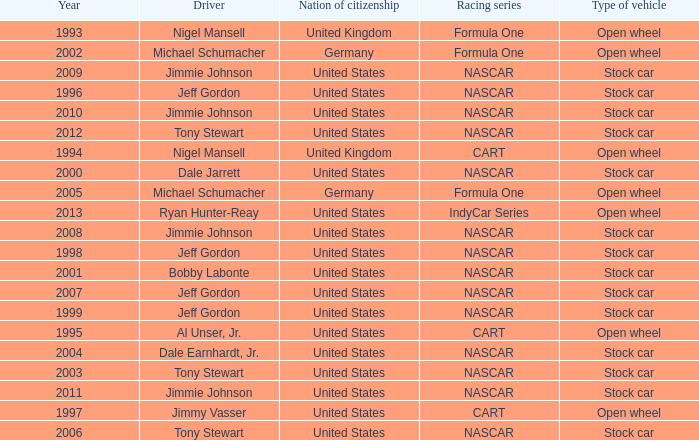Parse the table in full. {'header': ['Year', 'Driver', 'Nation of citizenship', 'Racing series', 'Type of vehicle'], 'rows': [['1993', 'Nigel Mansell', 'United Kingdom', 'Formula One', 'Open wheel'], ['2002', 'Michael Schumacher', 'Germany', 'Formula One', 'Open wheel'], ['2009', 'Jimmie Johnson', 'United States', 'NASCAR', 'Stock car'], ['1996', 'Jeff Gordon', 'United States', 'NASCAR', 'Stock car'], ['2010', 'Jimmie Johnson', 'United States', 'NASCAR', 'Stock car'], ['2012', 'Tony Stewart', 'United States', 'NASCAR', 'Stock car'], ['1994', 'Nigel Mansell', 'United Kingdom', 'CART', 'Open wheel'], ['2000', 'Dale Jarrett', 'United States', 'NASCAR', 'Stock car'], ['2005', 'Michael Schumacher', 'Germany', 'Formula One', 'Open wheel'], ['2013', 'Ryan Hunter-Reay', 'United States', 'IndyCar Series', 'Open wheel'], ['2008', 'Jimmie Johnson', 'United States', 'NASCAR', 'Stock car'], ['1998', 'Jeff Gordon', 'United States', 'NASCAR', 'Stock car'], ['2001', 'Bobby Labonte', 'United States', 'NASCAR', 'Stock car'], ['2007', 'Jeff Gordon', 'United States', 'NASCAR', 'Stock car'], ['1999', 'Jeff Gordon', 'United States', 'NASCAR', 'Stock car'], ['1995', 'Al Unser, Jr.', 'United States', 'CART', 'Open wheel'], ['2004', 'Dale Earnhardt, Jr.', 'United States', 'NASCAR', 'Stock car'], ['2003', 'Tony Stewart', 'United States', 'NASCAR', 'Stock car'], ['2011', 'Jimmie Johnson', 'United States', 'NASCAR', 'Stock car'], ['1997', 'Jimmy Vasser', 'United States', 'CART', 'Open wheel'], ['2006', 'Tony Stewart', 'United States', 'NASCAR', 'Stock car']]} What driver has a stock car vehicle with a year of 1999? Jeff Gordon. 